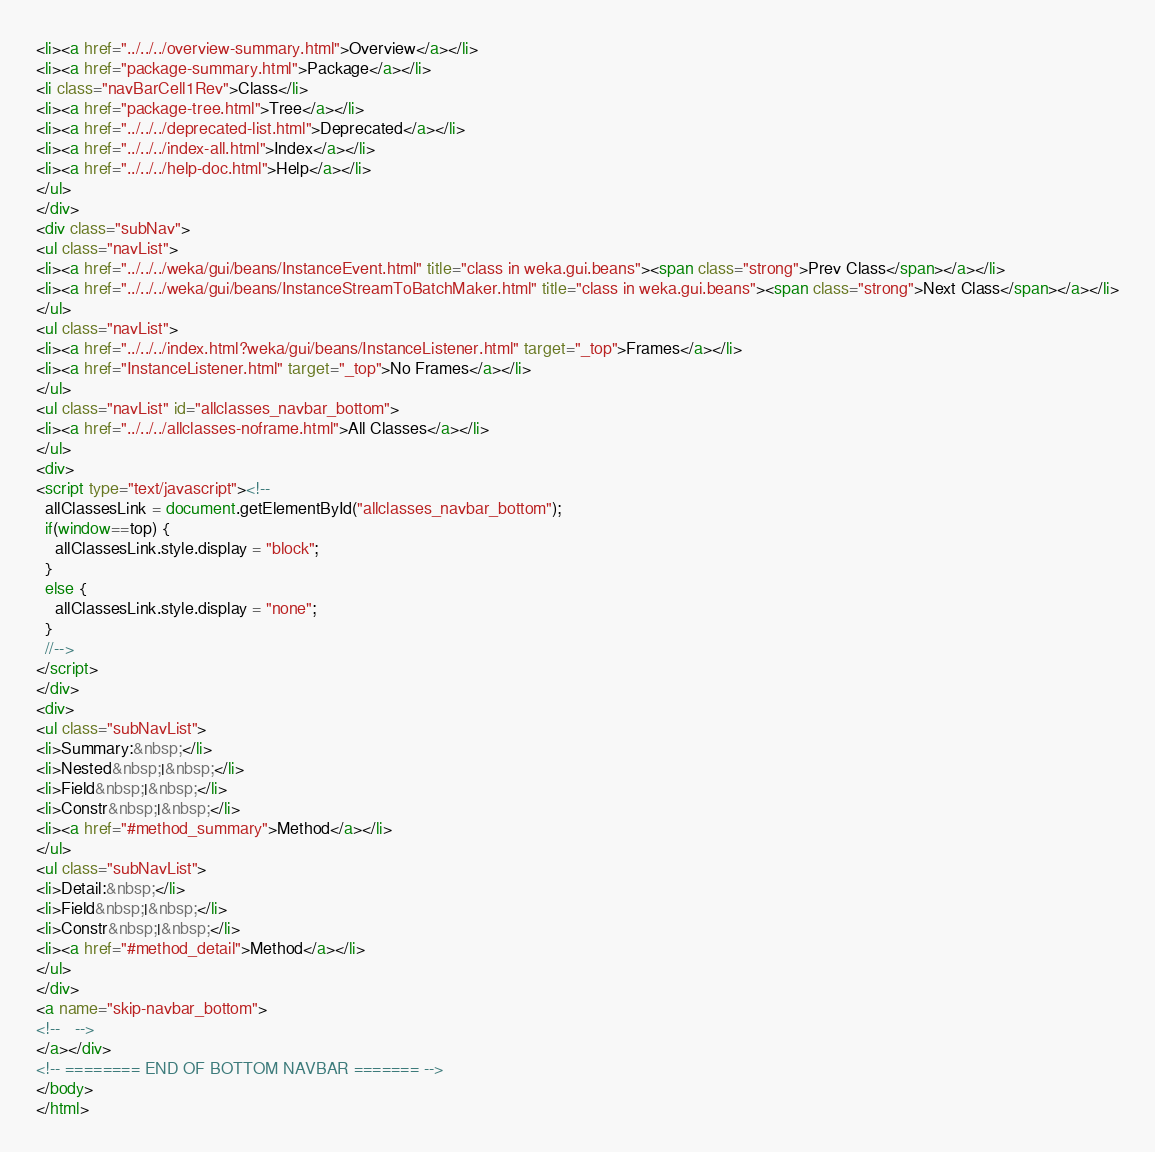<code> <loc_0><loc_0><loc_500><loc_500><_HTML_><li><a href="../../../overview-summary.html">Overview</a></li>
<li><a href="package-summary.html">Package</a></li>
<li class="navBarCell1Rev">Class</li>
<li><a href="package-tree.html">Tree</a></li>
<li><a href="../../../deprecated-list.html">Deprecated</a></li>
<li><a href="../../../index-all.html">Index</a></li>
<li><a href="../../../help-doc.html">Help</a></li>
</ul>
</div>
<div class="subNav">
<ul class="navList">
<li><a href="../../../weka/gui/beans/InstanceEvent.html" title="class in weka.gui.beans"><span class="strong">Prev Class</span></a></li>
<li><a href="../../../weka/gui/beans/InstanceStreamToBatchMaker.html" title="class in weka.gui.beans"><span class="strong">Next Class</span></a></li>
</ul>
<ul class="navList">
<li><a href="../../../index.html?weka/gui/beans/InstanceListener.html" target="_top">Frames</a></li>
<li><a href="InstanceListener.html" target="_top">No Frames</a></li>
</ul>
<ul class="navList" id="allclasses_navbar_bottom">
<li><a href="../../../allclasses-noframe.html">All Classes</a></li>
</ul>
<div>
<script type="text/javascript"><!--
  allClassesLink = document.getElementById("allclasses_navbar_bottom");
  if(window==top) {
    allClassesLink.style.display = "block";
  }
  else {
    allClassesLink.style.display = "none";
  }
  //-->
</script>
</div>
<div>
<ul class="subNavList">
<li>Summary:&nbsp;</li>
<li>Nested&nbsp;|&nbsp;</li>
<li>Field&nbsp;|&nbsp;</li>
<li>Constr&nbsp;|&nbsp;</li>
<li><a href="#method_summary">Method</a></li>
</ul>
<ul class="subNavList">
<li>Detail:&nbsp;</li>
<li>Field&nbsp;|&nbsp;</li>
<li>Constr&nbsp;|&nbsp;</li>
<li><a href="#method_detail">Method</a></li>
</ul>
</div>
<a name="skip-navbar_bottom">
<!--   -->
</a></div>
<!-- ======== END OF BOTTOM NAVBAR ======= -->
</body>
</html>
</code> 